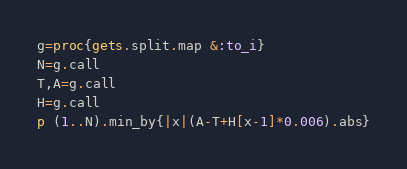<code> <loc_0><loc_0><loc_500><loc_500><_Ruby_>g=proc{gets.split.map &:to_i}
N=g.call
T,A=g.call
H=g.call
p (1..N).min_by{|x|(A-T+H[x-1]*0.006).abs}</code> 